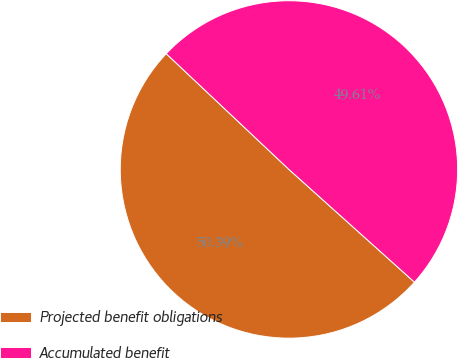<chart> <loc_0><loc_0><loc_500><loc_500><pie_chart><fcel>Projected benefit obligations<fcel>Accumulated benefit<nl><fcel>50.39%<fcel>49.61%<nl></chart> 